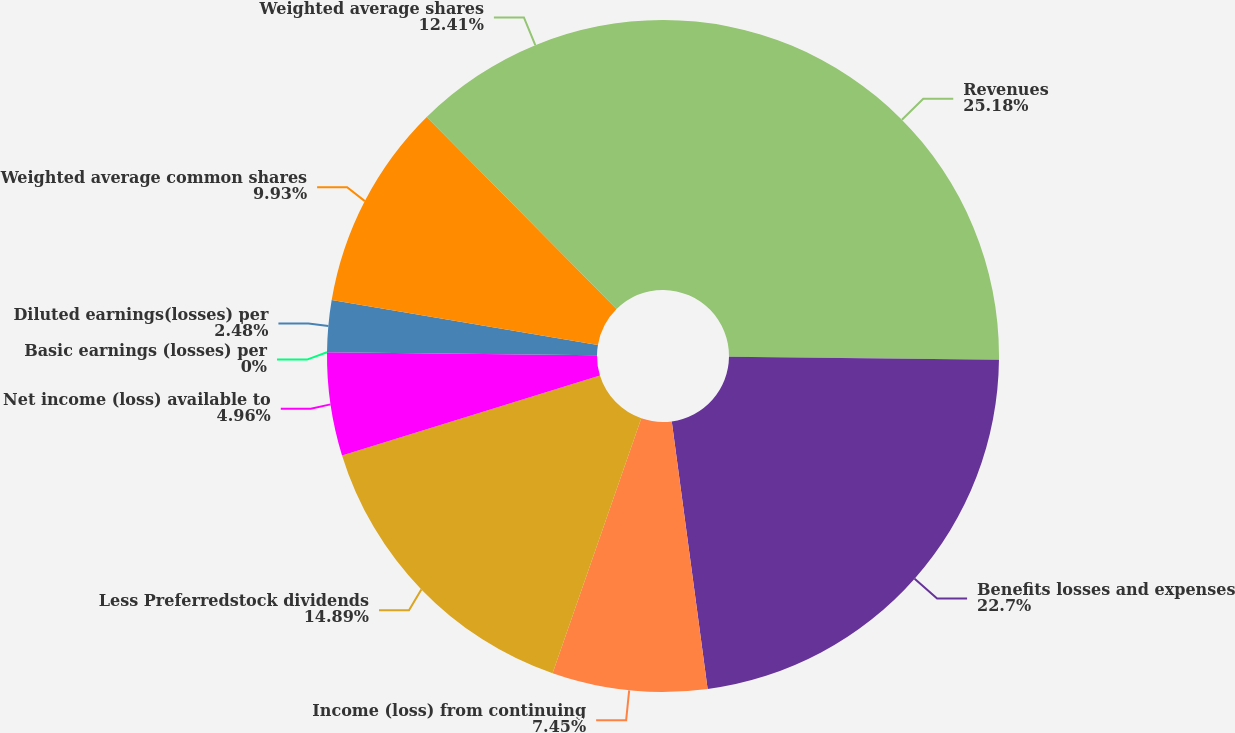Convert chart. <chart><loc_0><loc_0><loc_500><loc_500><pie_chart><fcel>Revenues<fcel>Benefits losses and expenses<fcel>Income (loss) from continuing<fcel>Less Preferredstock dividends<fcel>Net income (loss) available to<fcel>Basic earnings (losses) per<fcel>Diluted earnings(losses) per<fcel>Weighted average common shares<fcel>Weighted average shares<nl><fcel>25.18%<fcel>22.7%<fcel>7.45%<fcel>14.89%<fcel>4.96%<fcel>0.0%<fcel>2.48%<fcel>9.93%<fcel>12.41%<nl></chart> 